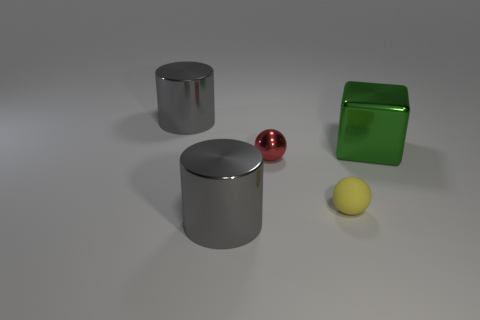Add 3 big green cubes. How many objects exist? 8 Subtract 1 cylinders. How many cylinders are left? 1 Subtract all balls. How many objects are left? 3 Add 1 green objects. How many green objects are left? 2 Add 4 yellow spheres. How many yellow spheres exist? 5 Subtract 2 gray cylinders. How many objects are left? 3 Subtract all yellow cylinders. Subtract all gray cubes. How many cylinders are left? 2 Subtract all small objects. Subtract all big gray cylinders. How many objects are left? 1 